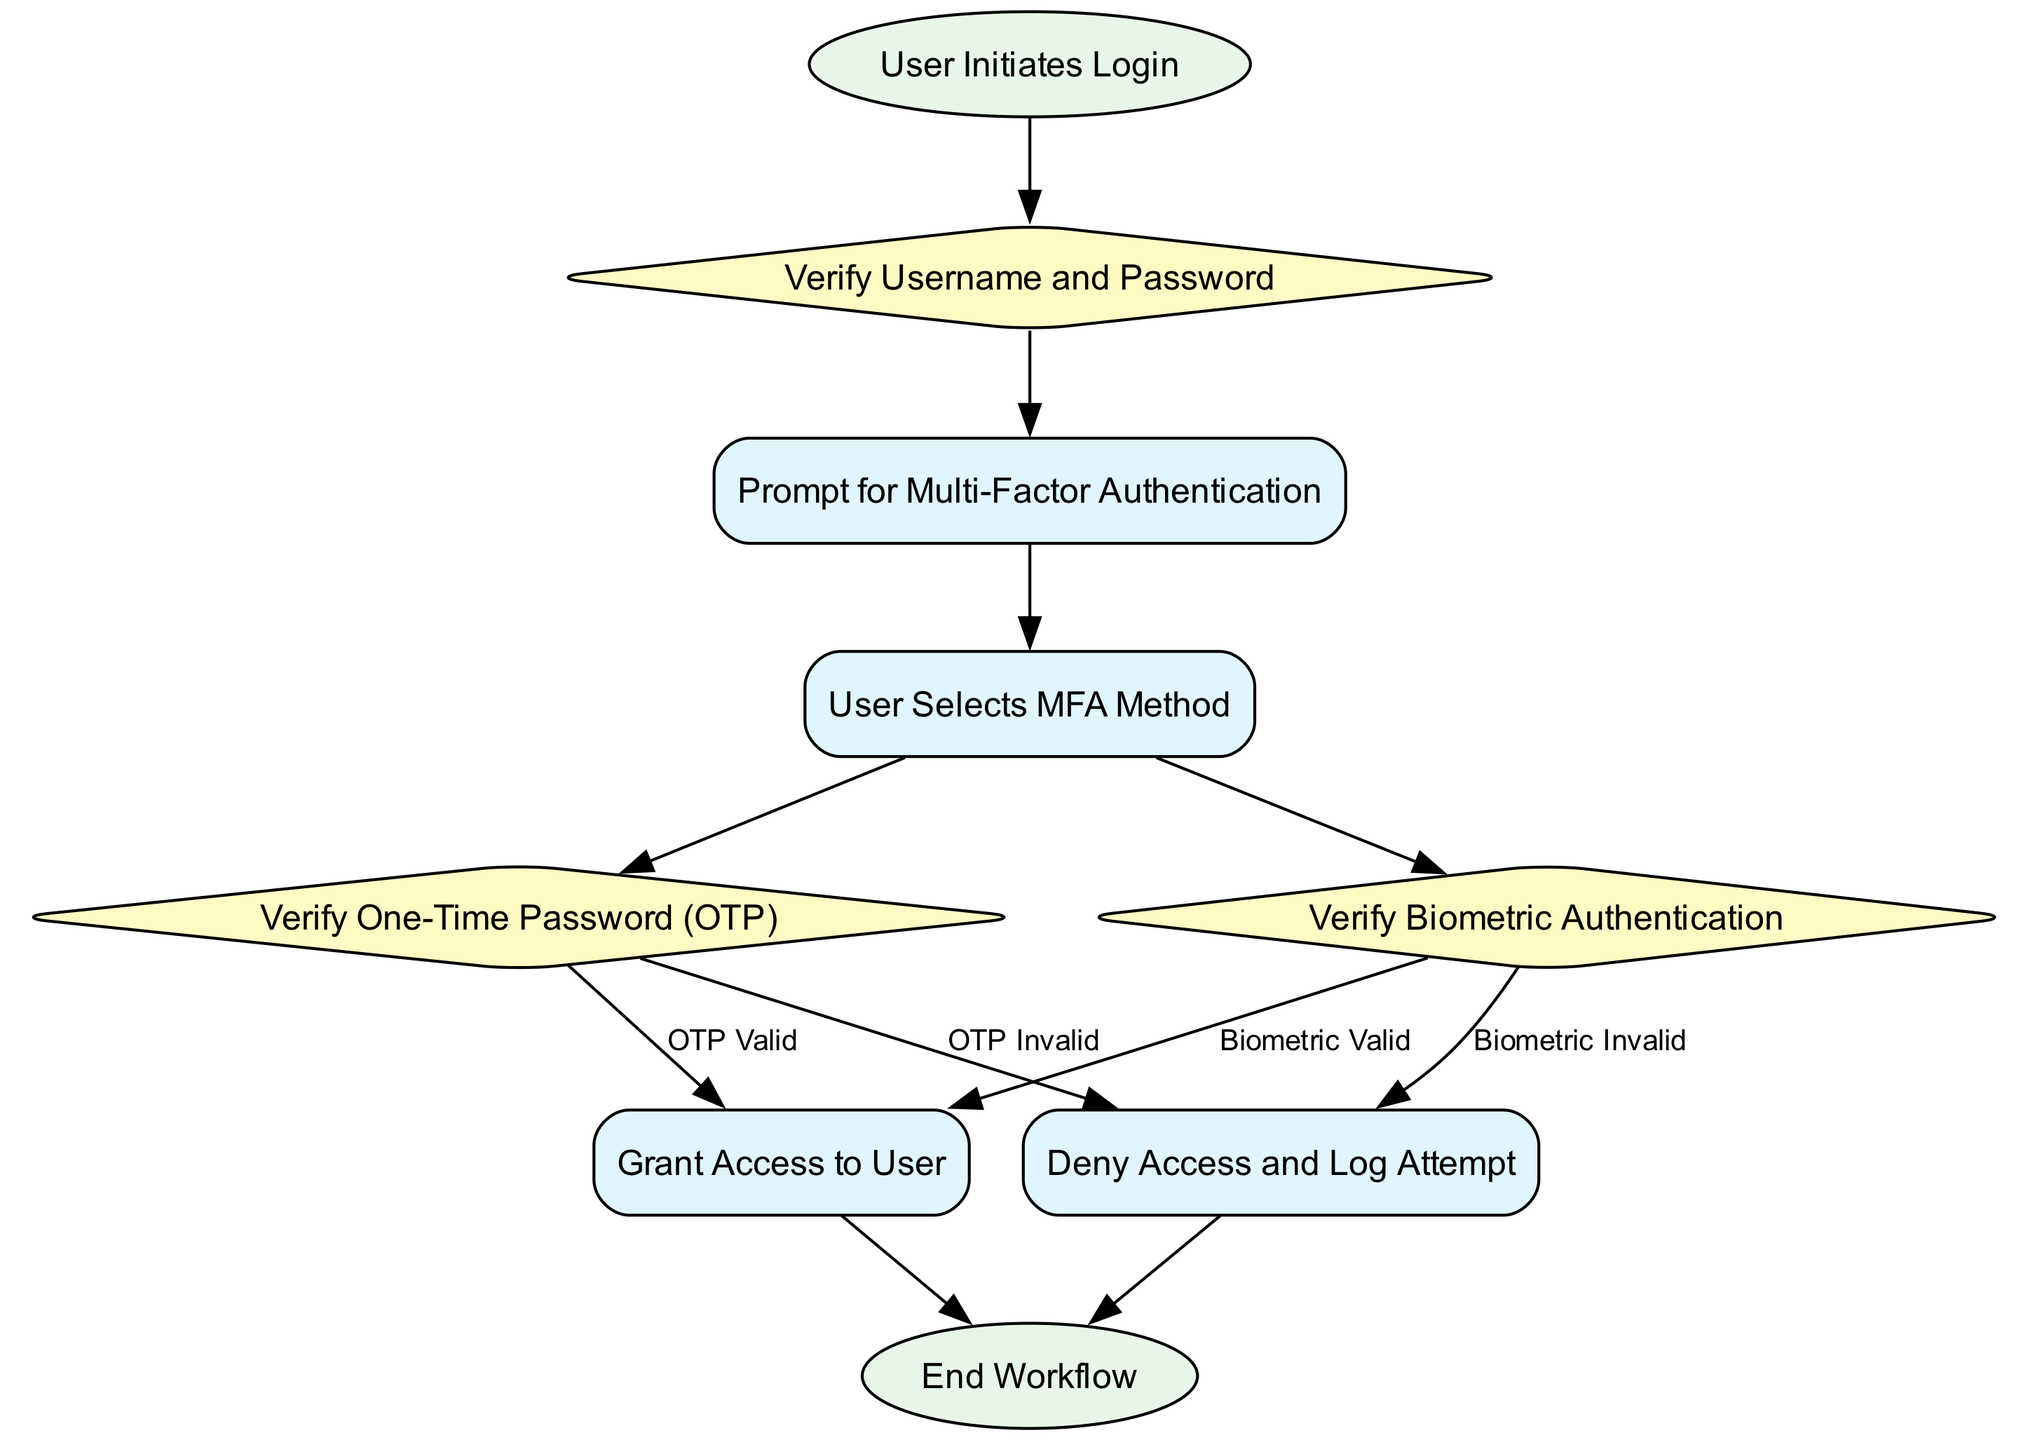What is the first step in the workflow? The workflow begins with the "User Initiates Login" process, which is the starting point of the diagram. This is the first action indicated in the flow chart.
Answer: User Initiates Login How many decision points are in the diagram? The diagram contains three decision points: "Verify Username and Password," "Verify One-Time Password (OTP)," and "Verify Biometric Authentication." Each of these represents a place where a decision must be made.
Answer: 3 What happens after the username and password verification? After the "Verify Username and Password" decision, the workflow proceeds to "Prompt for Multi-Factor Authentication," which is a process node that follows the decision node.
Answer: Prompt for Multi-Factor Authentication What are the conditions for granting access? Access is granted if either the OTP is valid or the biometric authentication is valid. Two paths lead to the "Grant Access to User" process based on these conditions.
Answer: OTP Valid or Biometric Valid What action is taken if the OTP is invalid? If the OTP is invalid, the workflow directs to the "Deny Access and Log Attempt" process, indicating that access is not granted, and an attempt is logged for security purposes.
Answer: Deny Access and Log Attempt Which node follows the "Grant Access to User"? After the "Grant Access to User" process, the workflow leads to the "End Workflow" process, marking the conclusion of the authentication process.
Answer: End Workflow What is the last process in the diagram? The last process in the diagram is "End Workflow," which signifies the termination of the multi-factor authentication workflow once access has been granted or denied.
Answer: End Workflow What happens if the biometric authentication is invalid? If the biometric authentication is invalid, the workflow goes to "Deny Access and Log Attempt," signifying that the user is not allowed access. This is similar to the process for invalid OTPs.
Answer: Deny Access and Log Attempt 